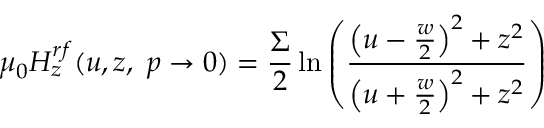<formula> <loc_0><loc_0><loc_500><loc_500>\mu _ { 0 } H _ { z } ^ { r f } ( u , z , p \rightarrow 0 ) = \frac { \Sigma } { 2 } \ln \left ( \frac { \left ( u - \frac { w } { 2 } \right ) ^ { 2 } + z ^ { 2 } } { \left ( u + \frac { w } { 2 } \right ) ^ { 2 } + z ^ { 2 } } \right )</formula> 